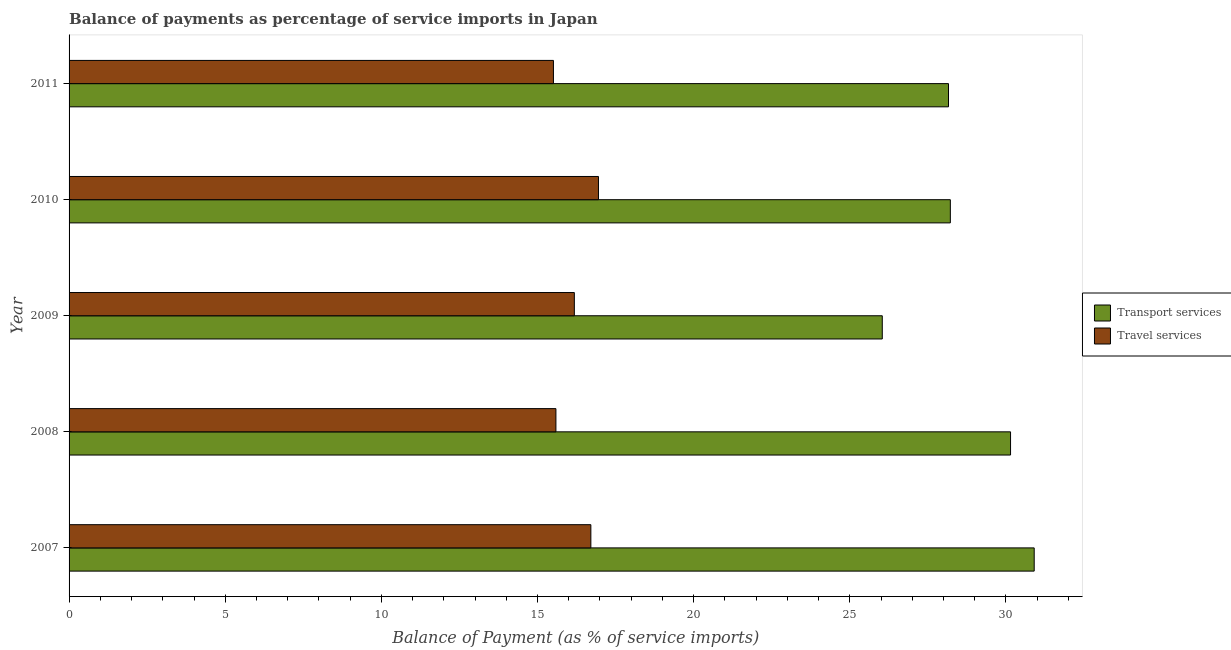How many different coloured bars are there?
Provide a succinct answer. 2. How many groups of bars are there?
Make the answer very short. 5. Are the number of bars on each tick of the Y-axis equal?
Provide a short and direct response. Yes. How many bars are there on the 5th tick from the top?
Your response must be concise. 2. How many bars are there on the 2nd tick from the bottom?
Make the answer very short. 2. In how many cases, is the number of bars for a given year not equal to the number of legend labels?
Your response must be concise. 0. What is the balance of payments of transport services in 2009?
Give a very brief answer. 26.04. Across all years, what is the maximum balance of payments of transport services?
Offer a very short reply. 30.9. Across all years, what is the minimum balance of payments of transport services?
Provide a short and direct response. 26.04. In which year was the balance of payments of transport services minimum?
Your response must be concise. 2009. What is the total balance of payments of transport services in the graph?
Your answer should be very brief. 143.47. What is the difference between the balance of payments of transport services in 2007 and that in 2011?
Keep it short and to the point. 2.74. What is the difference between the balance of payments of travel services in 2009 and the balance of payments of transport services in 2010?
Ensure brevity in your answer.  -12.04. What is the average balance of payments of transport services per year?
Your answer should be very brief. 28.69. In the year 2007, what is the difference between the balance of payments of travel services and balance of payments of transport services?
Ensure brevity in your answer.  -14.2. What is the ratio of the balance of payments of transport services in 2008 to that in 2009?
Keep it short and to the point. 1.16. Is the difference between the balance of payments of transport services in 2009 and 2010 greater than the difference between the balance of payments of travel services in 2009 and 2010?
Make the answer very short. No. What is the difference between the highest and the second highest balance of payments of travel services?
Provide a succinct answer. 0.24. What is the difference between the highest and the lowest balance of payments of travel services?
Ensure brevity in your answer.  1.44. In how many years, is the balance of payments of transport services greater than the average balance of payments of transport services taken over all years?
Ensure brevity in your answer.  2. Is the sum of the balance of payments of transport services in 2007 and 2011 greater than the maximum balance of payments of travel services across all years?
Ensure brevity in your answer.  Yes. What does the 1st bar from the top in 2008 represents?
Make the answer very short. Travel services. What does the 2nd bar from the bottom in 2010 represents?
Offer a very short reply. Travel services. Are all the bars in the graph horizontal?
Give a very brief answer. Yes. How many years are there in the graph?
Your response must be concise. 5. What is the difference between two consecutive major ticks on the X-axis?
Offer a very short reply. 5. Are the values on the major ticks of X-axis written in scientific E-notation?
Your answer should be compact. No. How are the legend labels stacked?
Ensure brevity in your answer.  Vertical. What is the title of the graph?
Keep it short and to the point. Balance of payments as percentage of service imports in Japan. Does "GDP at market prices" appear as one of the legend labels in the graph?
Ensure brevity in your answer.  No. What is the label or title of the X-axis?
Give a very brief answer. Balance of Payment (as % of service imports). What is the Balance of Payment (as % of service imports) of Transport services in 2007?
Offer a terse response. 30.9. What is the Balance of Payment (as % of service imports) of Travel services in 2007?
Offer a terse response. 16.71. What is the Balance of Payment (as % of service imports) of Transport services in 2008?
Keep it short and to the point. 30.15. What is the Balance of Payment (as % of service imports) in Travel services in 2008?
Your response must be concise. 15.59. What is the Balance of Payment (as % of service imports) in Transport services in 2009?
Offer a very short reply. 26.04. What is the Balance of Payment (as % of service imports) in Travel services in 2009?
Provide a short and direct response. 16.18. What is the Balance of Payment (as % of service imports) in Transport services in 2010?
Your response must be concise. 28.22. What is the Balance of Payment (as % of service imports) of Travel services in 2010?
Give a very brief answer. 16.95. What is the Balance of Payment (as % of service imports) of Transport services in 2011?
Provide a short and direct response. 28.16. What is the Balance of Payment (as % of service imports) of Travel services in 2011?
Offer a very short reply. 15.51. Across all years, what is the maximum Balance of Payment (as % of service imports) in Transport services?
Provide a short and direct response. 30.9. Across all years, what is the maximum Balance of Payment (as % of service imports) of Travel services?
Ensure brevity in your answer.  16.95. Across all years, what is the minimum Balance of Payment (as % of service imports) of Transport services?
Your answer should be very brief. 26.04. Across all years, what is the minimum Balance of Payment (as % of service imports) in Travel services?
Your answer should be compact. 15.51. What is the total Balance of Payment (as % of service imports) of Transport services in the graph?
Make the answer very short. 143.47. What is the total Balance of Payment (as % of service imports) of Travel services in the graph?
Provide a short and direct response. 80.94. What is the difference between the Balance of Payment (as % of service imports) in Transport services in 2007 and that in 2008?
Provide a short and direct response. 0.76. What is the difference between the Balance of Payment (as % of service imports) in Travel services in 2007 and that in 2008?
Give a very brief answer. 1.12. What is the difference between the Balance of Payment (as % of service imports) in Transport services in 2007 and that in 2009?
Give a very brief answer. 4.86. What is the difference between the Balance of Payment (as % of service imports) in Travel services in 2007 and that in 2009?
Provide a succinct answer. 0.53. What is the difference between the Balance of Payment (as % of service imports) of Transport services in 2007 and that in 2010?
Your answer should be compact. 2.69. What is the difference between the Balance of Payment (as % of service imports) in Travel services in 2007 and that in 2010?
Your response must be concise. -0.24. What is the difference between the Balance of Payment (as % of service imports) in Transport services in 2007 and that in 2011?
Your answer should be very brief. 2.74. What is the difference between the Balance of Payment (as % of service imports) of Travel services in 2007 and that in 2011?
Offer a very short reply. 1.2. What is the difference between the Balance of Payment (as % of service imports) of Transport services in 2008 and that in 2009?
Your answer should be very brief. 4.11. What is the difference between the Balance of Payment (as % of service imports) of Travel services in 2008 and that in 2009?
Provide a succinct answer. -0.59. What is the difference between the Balance of Payment (as % of service imports) in Transport services in 2008 and that in 2010?
Give a very brief answer. 1.93. What is the difference between the Balance of Payment (as % of service imports) of Travel services in 2008 and that in 2010?
Ensure brevity in your answer.  -1.36. What is the difference between the Balance of Payment (as % of service imports) of Transport services in 2008 and that in 2011?
Offer a terse response. 1.99. What is the difference between the Balance of Payment (as % of service imports) in Travel services in 2008 and that in 2011?
Give a very brief answer. 0.08. What is the difference between the Balance of Payment (as % of service imports) of Transport services in 2009 and that in 2010?
Your answer should be compact. -2.18. What is the difference between the Balance of Payment (as % of service imports) in Travel services in 2009 and that in 2010?
Your answer should be very brief. -0.77. What is the difference between the Balance of Payment (as % of service imports) in Transport services in 2009 and that in 2011?
Your answer should be compact. -2.12. What is the difference between the Balance of Payment (as % of service imports) in Travel services in 2009 and that in 2011?
Offer a very short reply. 0.67. What is the difference between the Balance of Payment (as % of service imports) of Transport services in 2010 and that in 2011?
Your answer should be compact. 0.06. What is the difference between the Balance of Payment (as % of service imports) in Travel services in 2010 and that in 2011?
Offer a very short reply. 1.44. What is the difference between the Balance of Payment (as % of service imports) of Transport services in 2007 and the Balance of Payment (as % of service imports) of Travel services in 2008?
Give a very brief answer. 15.31. What is the difference between the Balance of Payment (as % of service imports) in Transport services in 2007 and the Balance of Payment (as % of service imports) in Travel services in 2009?
Your answer should be compact. 14.72. What is the difference between the Balance of Payment (as % of service imports) of Transport services in 2007 and the Balance of Payment (as % of service imports) of Travel services in 2010?
Your answer should be compact. 13.95. What is the difference between the Balance of Payment (as % of service imports) of Transport services in 2007 and the Balance of Payment (as % of service imports) of Travel services in 2011?
Ensure brevity in your answer.  15.39. What is the difference between the Balance of Payment (as % of service imports) in Transport services in 2008 and the Balance of Payment (as % of service imports) in Travel services in 2009?
Keep it short and to the point. 13.97. What is the difference between the Balance of Payment (as % of service imports) in Transport services in 2008 and the Balance of Payment (as % of service imports) in Travel services in 2010?
Your response must be concise. 13.19. What is the difference between the Balance of Payment (as % of service imports) of Transport services in 2008 and the Balance of Payment (as % of service imports) of Travel services in 2011?
Keep it short and to the point. 14.64. What is the difference between the Balance of Payment (as % of service imports) in Transport services in 2009 and the Balance of Payment (as % of service imports) in Travel services in 2010?
Give a very brief answer. 9.09. What is the difference between the Balance of Payment (as % of service imports) in Transport services in 2009 and the Balance of Payment (as % of service imports) in Travel services in 2011?
Offer a very short reply. 10.53. What is the difference between the Balance of Payment (as % of service imports) of Transport services in 2010 and the Balance of Payment (as % of service imports) of Travel services in 2011?
Your answer should be compact. 12.71. What is the average Balance of Payment (as % of service imports) of Transport services per year?
Your answer should be compact. 28.69. What is the average Balance of Payment (as % of service imports) of Travel services per year?
Ensure brevity in your answer.  16.19. In the year 2007, what is the difference between the Balance of Payment (as % of service imports) of Transport services and Balance of Payment (as % of service imports) of Travel services?
Your answer should be very brief. 14.2. In the year 2008, what is the difference between the Balance of Payment (as % of service imports) of Transport services and Balance of Payment (as % of service imports) of Travel services?
Ensure brevity in your answer.  14.56. In the year 2009, what is the difference between the Balance of Payment (as % of service imports) in Transport services and Balance of Payment (as % of service imports) in Travel services?
Make the answer very short. 9.86. In the year 2010, what is the difference between the Balance of Payment (as % of service imports) of Transport services and Balance of Payment (as % of service imports) of Travel services?
Provide a short and direct response. 11.27. In the year 2011, what is the difference between the Balance of Payment (as % of service imports) in Transport services and Balance of Payment (as % of service imports) in Travel services?
Provide a succinct answer. 12.65. What is the ratio of the Balance of Payment (as % of service imports) in Transport services in 2007 to that in 2008?
Your response must be concise. 1.03. What is the ratio of the Balance of Payment (as % of service imports) of Travel services in 2007 to that in 2008?
Keep it short and to the point. 1.07. What is the ratio of the Balance of Payment (as % of service imports) of Transport services in 2007 to that in 2009?
Offer a very short reply. 1.19. What is the ratio of the Balance of Payment (as % of service imports) in Travel services in 2007 to that in 2009?
Provide a succinct answer. 1.03. What is the ratio of the Balance of Payment (as % of service imports) of Transport services in 2007 to that in 2010?
Provide a short and direct response. 1.1. What is the ratio of the Balance of Payment (as % of service imports) of Travel services in 2007 to that in 2010?
Your response must be concise. 0.99. What is the ratio of the Balance of Payment (as % of service imports) of Transport services in 2007 to that in 2011?
Provide a short and direct response. 1.1. What is the ratio of the Balance of Payment (as % of service imports) in Travel services in 2007 to that in 2011?
Keep it short and to the point. 1.08. What is the ratio of the Balance of Payment (as % of service imports) of Transport services in 2008 to that in 2009?
Your answer should be compact. 1.16. What is the ratio of the Balance of Payment (as % of service imports) in Travel services in 2008 to that in 2009?
Give a very brief answer. 0.96. What is the ratio of the Balance of Payment (as % of service imports) of Transport services in 2008 to that in 2010?
Your answer should be compact. 1.07. What is the ratio of the Balance of Payment (as % of service imports) in Travel services in 2008 to that in 2010?
Provide a short and direct response. 0.92. What is the ratio of the Balance of Payment (as % of service imports) of Transport services in 2008 to that in 2011?
Keep it short and to the point. 1.07. What is the ratio of the Balance of Payment (as % of service imports) of Transport services in 2009 to that in 2010?
Offer a very short reply. 0.92. What is the ratio of the Balance of Payment (as % of service imports) in Travel services in 2009 to that in 2010?
Offer a very short reply. 0.95. What is the ratio of the Balance of Payment (as % of service imports) of Transport services in 2009 to that in 2011?
Ensure brevity in your answer.  0.92. What is the ratio of the Balance of Payment (as % of service imports) in Travel services in 2009 to that in 2011?
Ensure brevity in your answer.  1.04. What is the ratio of the Balance of Payment (as % of service imports) of Transport services in 2010 to that in 2011?
Provide a succinct answer. 1. What is the ratio of the Balance of Payment (as % of service imports) in Travel services in 2010 to that in 2011?
Offer a terse response. 1.09. What is the difference between the highest and the second highest Balance of Payment (as % of service imports) of Transport services?
Provide a succinct answer. 0.76. What is the difference between the highest and the second highest Balance of Payment (as % of service imports) in Travel services?
Ensure brevity in your answer.  0.24. What is the difference between the highest and the lowest Balance of Payment (as % of service imports) of Transport services?
Offer a very short reply. 4.86. What is the difference between the highest and the lowest Balance of Payment (as % of service imports) of Travel services?
Ensure brevity in your answer.  1.44. 